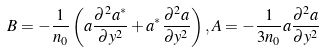Convert formula to latex. <formula><loc_0><loc_0><loc_500><loc_500>B = - \frac { 1 } { n _ { 0 } } \left ( a \frac { \partial ^ { 2 } a ^ { * } } { \partial y ^ { 2 } } + a ^ { * } \frac { \partial ^ { 2 } a } { \partial y ^ { 2 } } \right ) , A = - \frac { 1 } { 3 n _ { 0 } } a \frac { \partial ^ { 2 } a } { \partial y ^ { 2 } }</formula> 